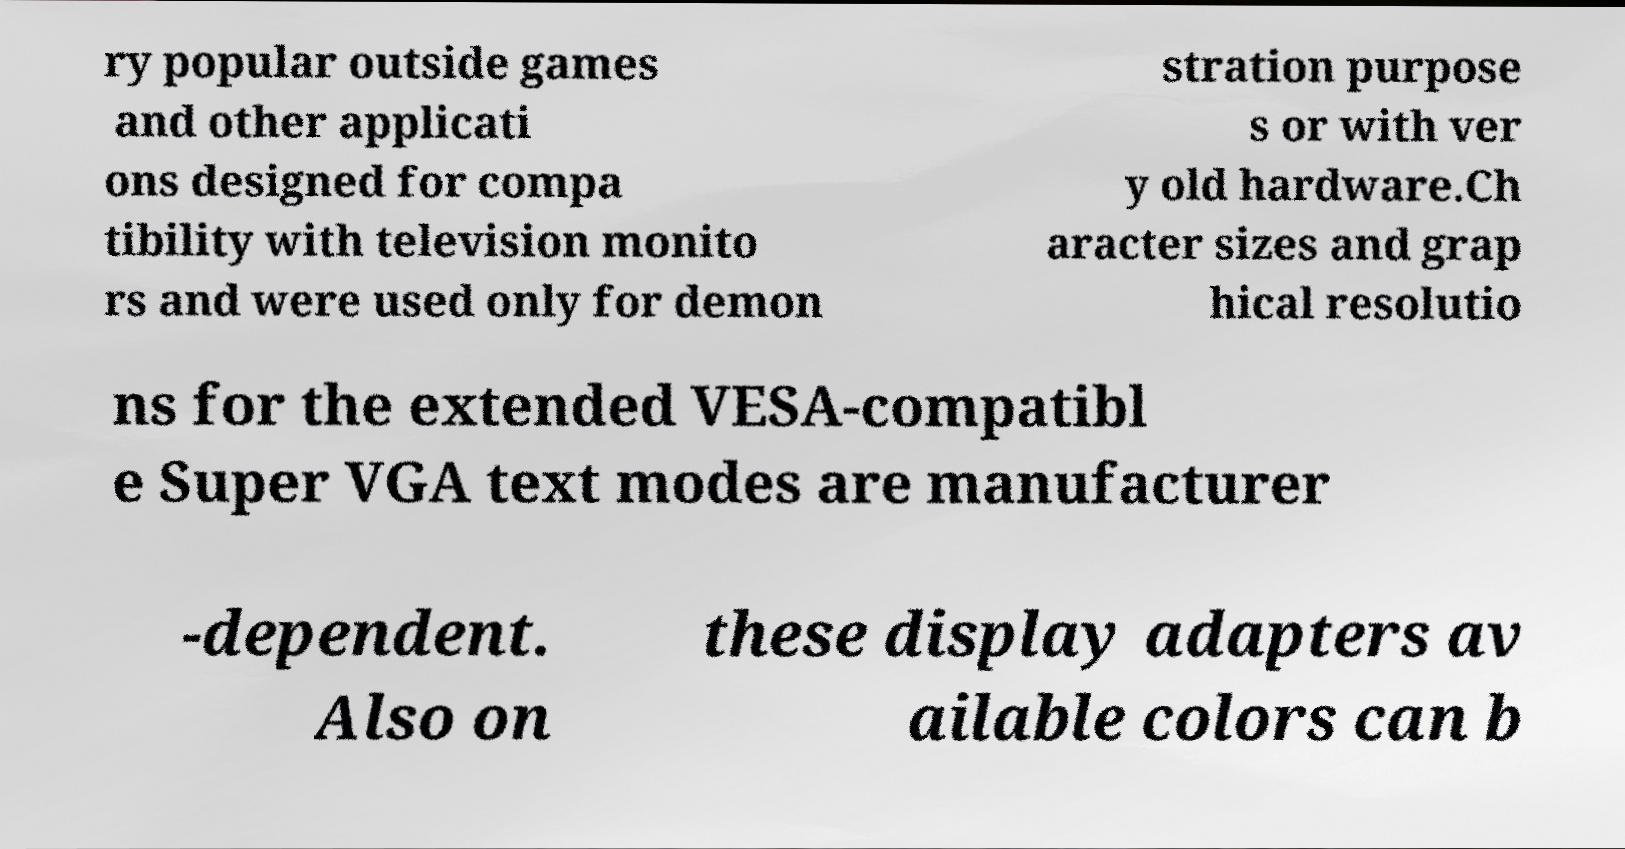I need the written content from this picture converted into text. Can you do that? ry popular outside games and other applicati ons designed for compa tibility with television monito rs and were used only for demon stration purpose s or with ver y old hardware.Ch aracter sizes and grap hical resolutio ns for the extended VESA-compatibl e Super VGA text modes are manufacturer -dependent. Also on these display adapters av ailable colors can b 